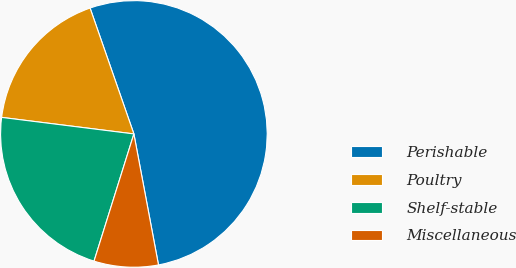<chart> <loc_0><loc_0><loc_500><loc_500><pie_chart><fcel>Perishable<fcel>Poultry<fcel>Shelf-stable<fcel>Miscellaneous<nl><fcel>52.38%<fcel>17.69%<fcel>22.15%<fcel>7.79%<nl></chart> 